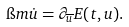<formula> <loc_0><loc_0><loc_500><loc_500>\i m \dot { u } = \partial _ { \overline { u } } E ( t , u ) .</formula> 